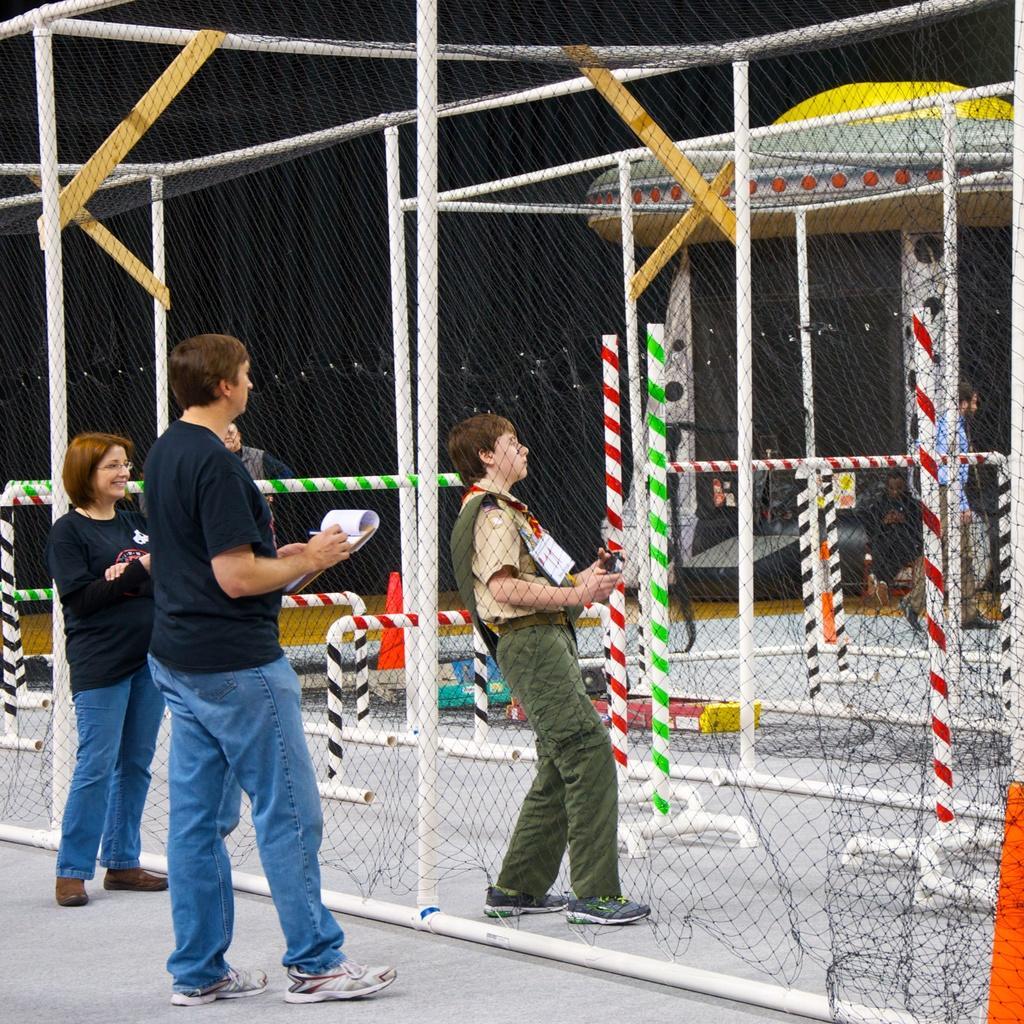How would you summarize this image in a sentence or two? In this image we can see people. The man standing in the center is holding a book. In the background there are poles, net and cones. 